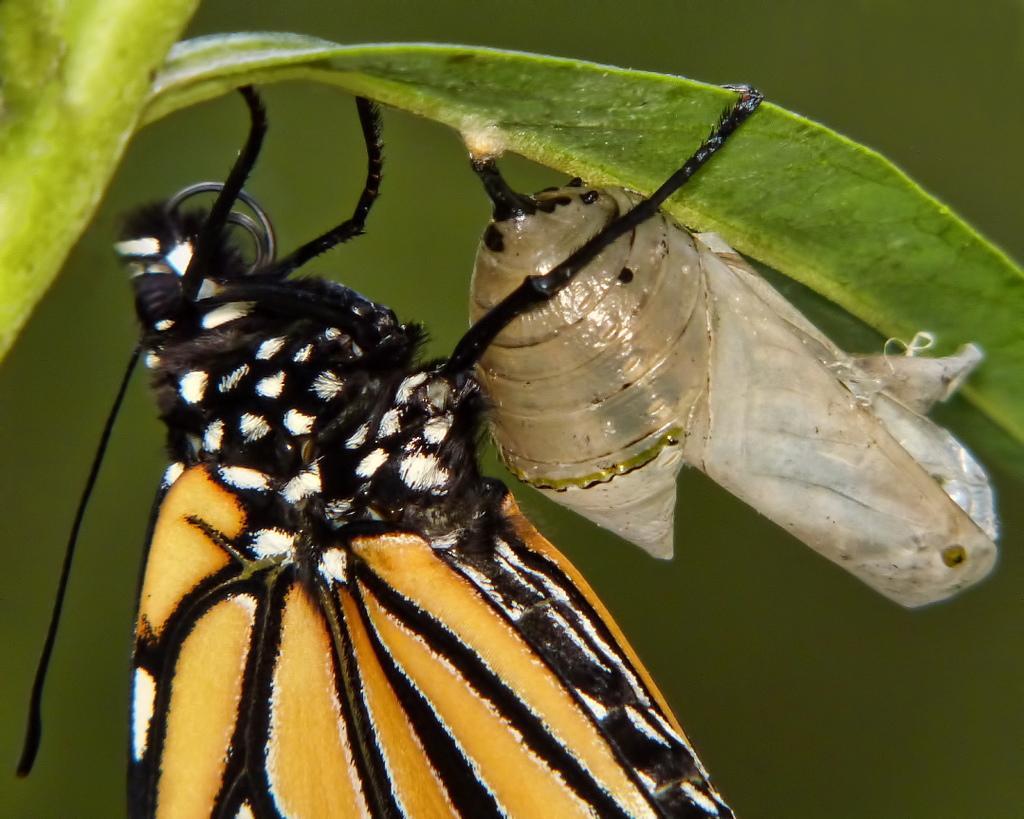Describe this image in one or two sentences. In this image we can see insect on the leaf. The background of the image is blur. 